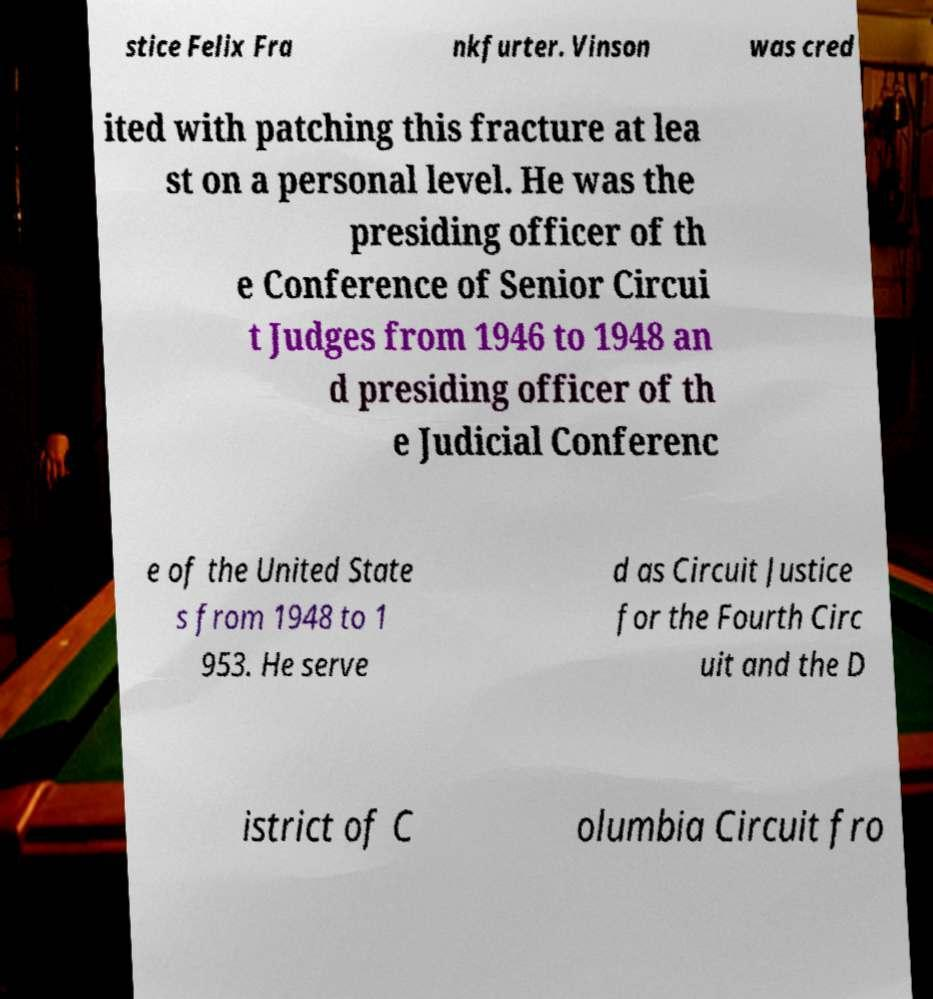There's text embedded in this image that I need extracted. Can you transcribe it verbatim? stice Felix Fra nkfurter. Vinson was cred ited with patching this fracture at lea st on a personal level. He was the presiding officer of th e Conference of Senior Circui t Judges from 1946 to 1948 an d presiding officer of th e Judicial Conferenc e of the United State s from 1948 to 1 953. He serve d as Circuit Justice for the Fourth Circ uit and the D istrict of C olumbia Circuit fro 